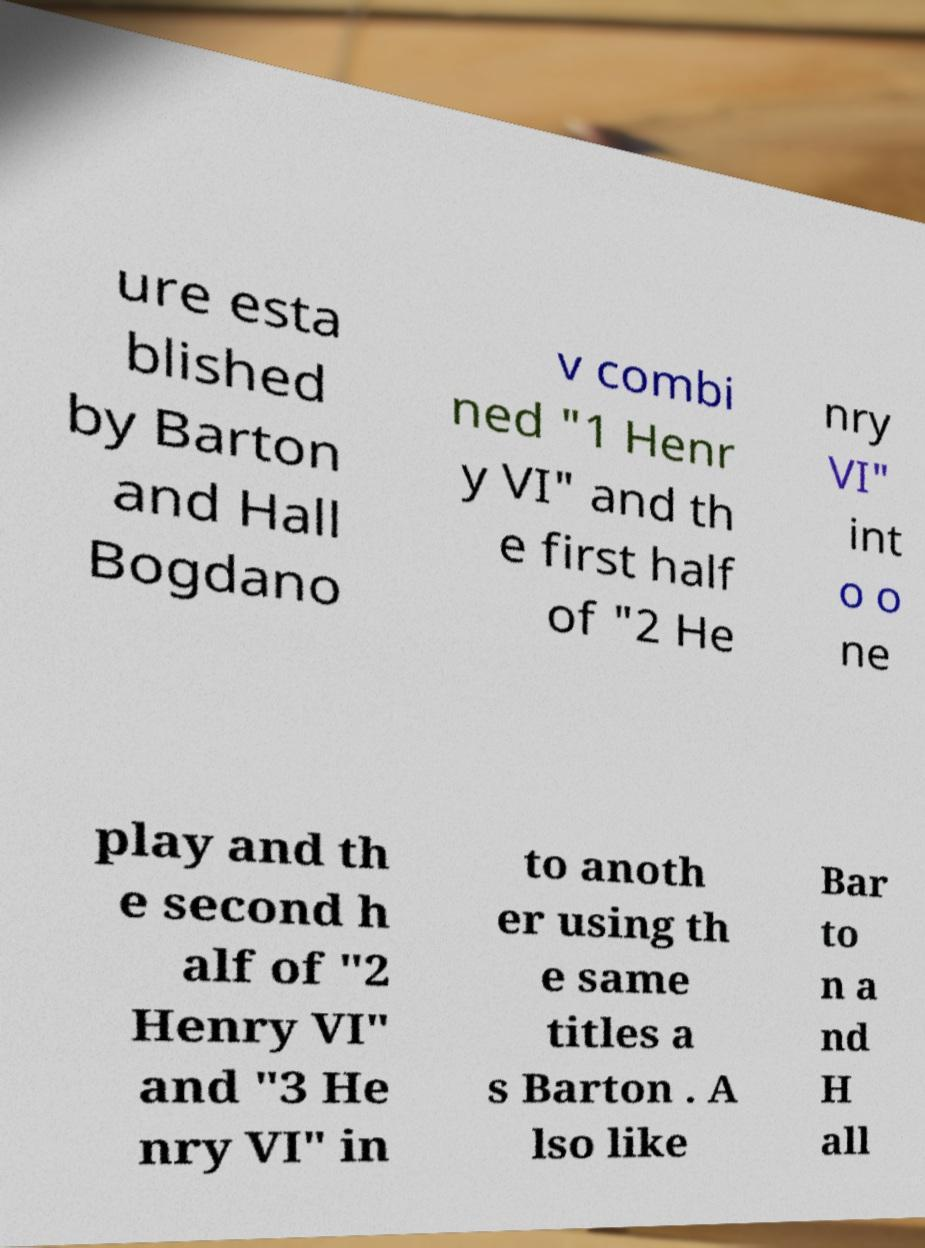Can you accurately transcribe the text from the provided image for me? ure esta blished by Barton and Hall Bogdano v combi ned "1 Henr y VI" and th e first half of "2 He nry VI" int o o ne play and th e second h alf of "2 Henry VI" and "3 He nry VI" in to anoth er using th e same titles a s Barton . A lso like Bar to n a nd H all 